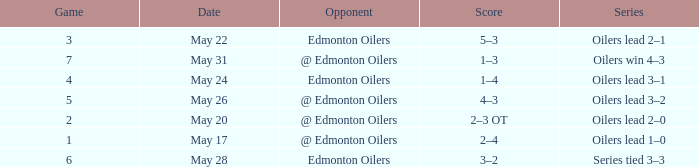Which game featured the highest score in the series where the oilers emerged victorious with a 4-3 win? 7.0. 